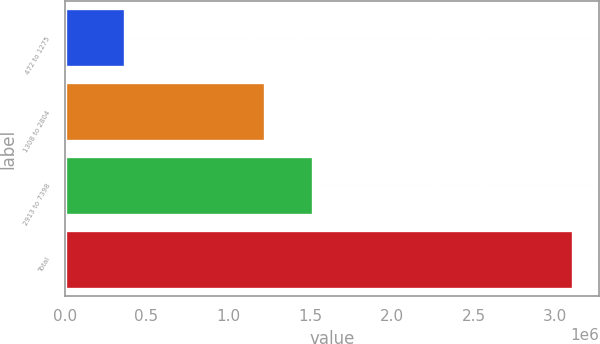<chart> <loc_0><loc_0><loc_500><loc_500><bar_chart><fcel>472 to 1275<fcel>1308 to 2804<fcel>2913 to 7398<fcel>Total<nl><fcel>366523<fcel>1.22473e+06<fcel>1.51921e+06<fcel>3.11046e+06<nl></chart> 